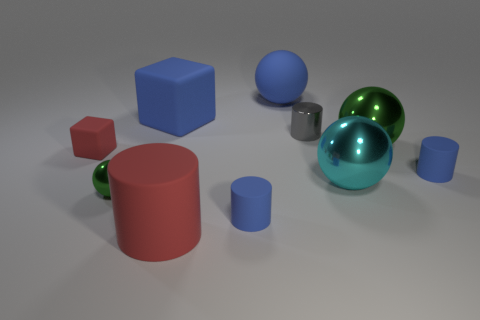Subtract all blocks. How many objects are left? 8 Add 4 gray cylinders. How many gray cylinders are left? 5 Add 3 red cylinders. How many red cylinders exist? 4 Subtract 0 brown cylinders. How many objects are left? 10 Subtract all blue rubber blocks. Subtract all big blocks. How many objects are left? 8 